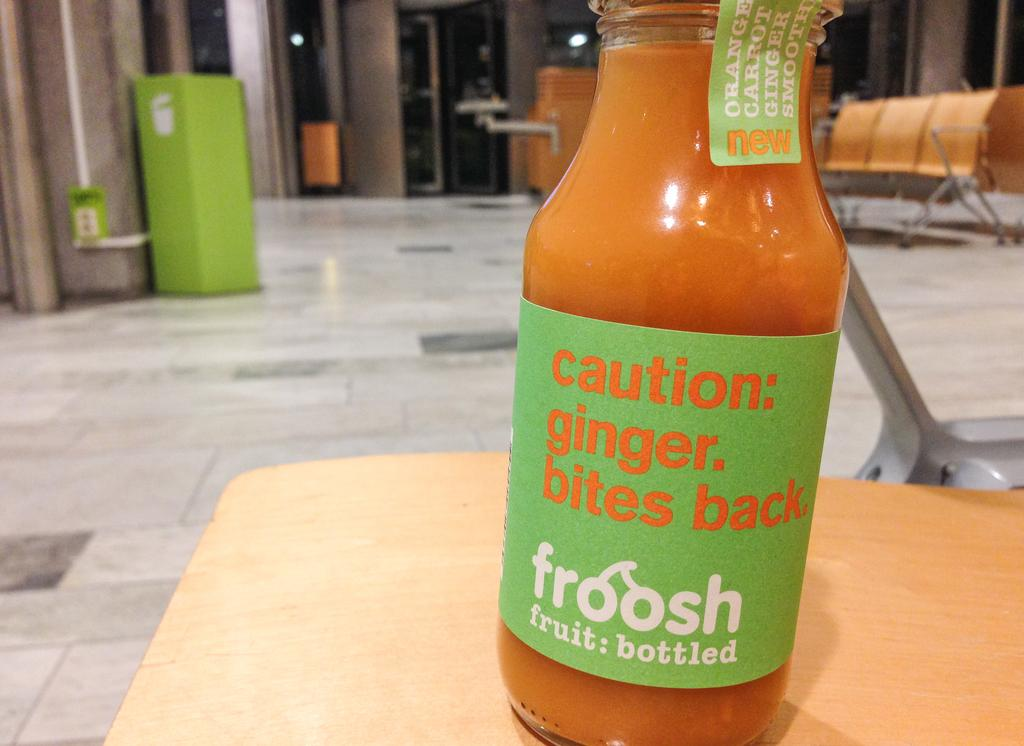Provide a one-sentence caption for the provided image. The froosh (fruit: bottled) new orange, carrot, and ginger smoothie includes a "caution: ginger. bites back."!. 